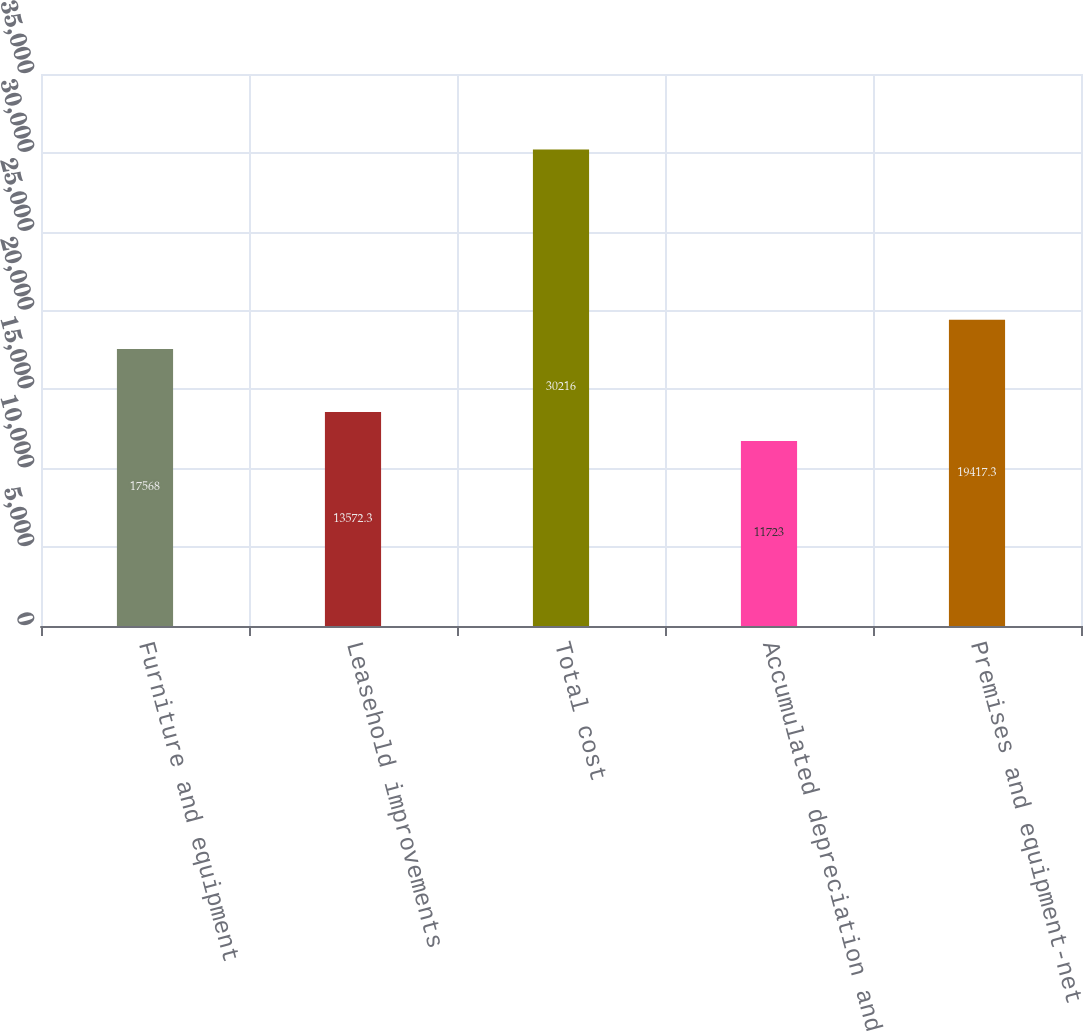Convert chart to OTSL. <chart><loc_0><loc_0><loc_500><loc_500><bar_chart><fcel>Furniture and equipment<fcel>Leasehold improvements<fcel>Total cost<fcel>Accumulated depreciation and<fcel>Premises and equipment-net<nl><fcel>17568<fcel>13572.3<fcel>30216<fcel>11723<fcel>19417.3<nl></chart> 